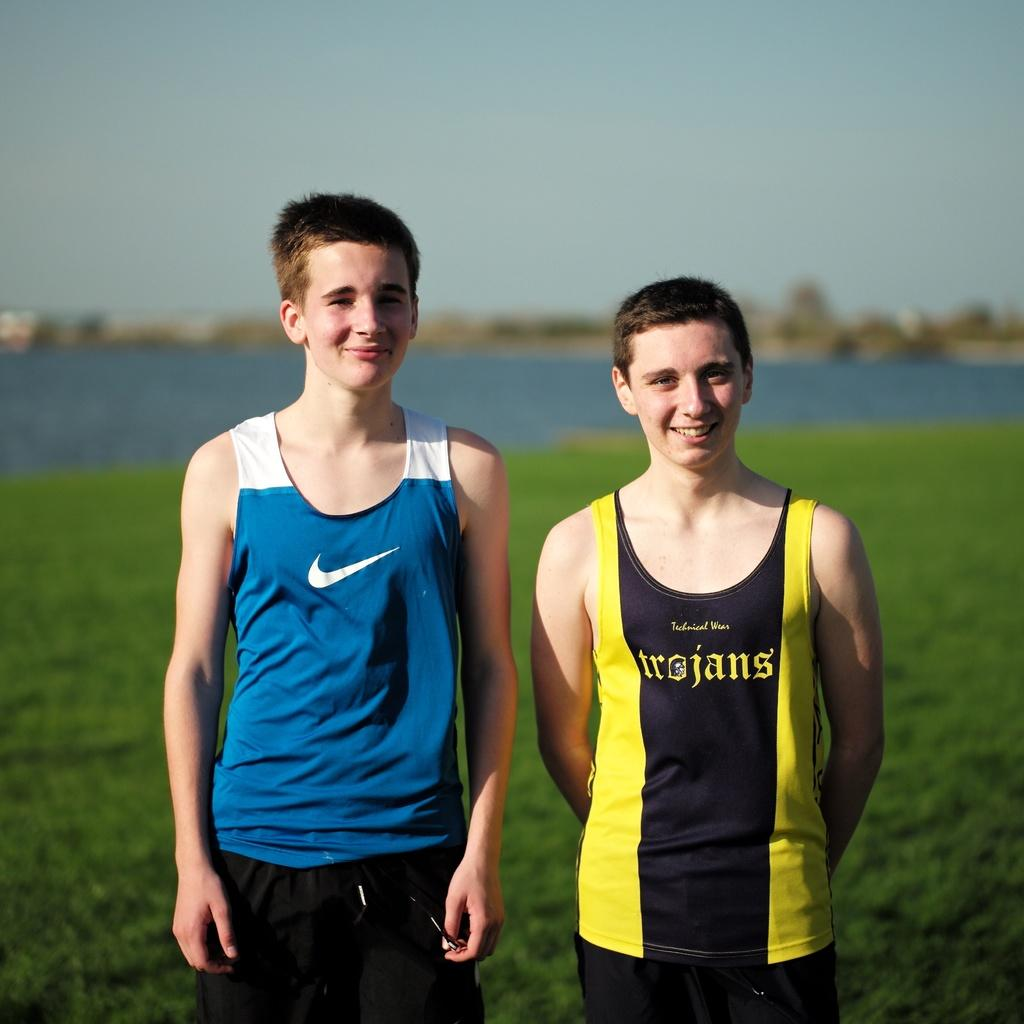<image>
Present a compact description of the photo's key features. Two boys standing on grass, one with a blue tank top with a white Nike swoosh and the other with a yellow and black tank top that says trojans. 